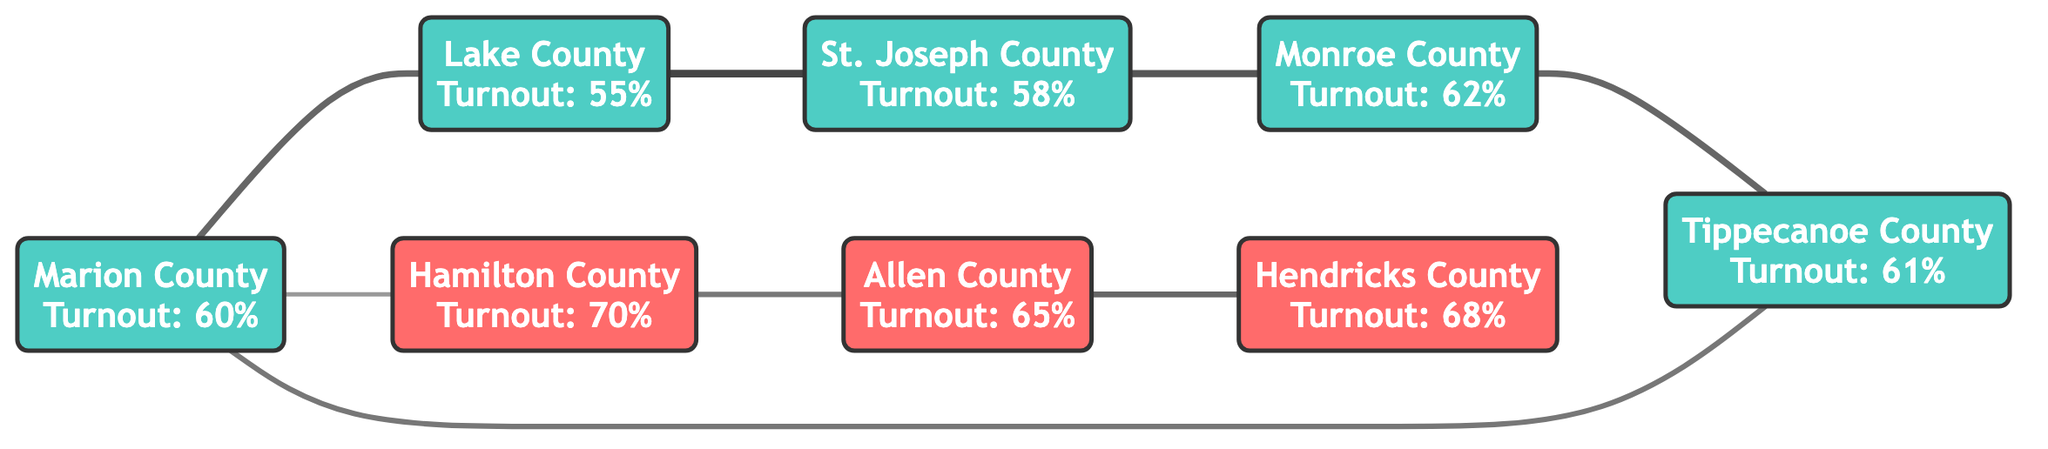What is the voter turnout percentage for Marion County? The diagram indicates the voter turnout for Marion County is specifically annotated as 60%.
Answer: 60% What party affiliation does Hamilton County have? The diagram shows that Hamilton County is categorized as having a Republican party affiliation.
Answer: Republican How many edges are present in the diagram? By counting the connections between the counties, there are a total of 8 edges indicated in the diagram.
Answer: 8 Which county has the highest voter turnout? By comparing the voter turnout percentages, Hamilton County has the highest voter turnout of 70% among the listed counties.
Answer: Hamilton County What is the similarity score between Allen County and Hendricks County? The similarity score that connects Allen County and Hendricks County is listed as 0.65 in the edges.
Answer: 0.65 Which counties are connected to St. Joseph County? St. Joseph County is directly connected to Lake County and Monroe County according to the edges shown in the diagram.
Answer: Lake County, Monroe County What is the lowest voter turnout percentage among the counties? Upon reviewing the turnout percentages, Lake County has the lowest voter turnout at 55%.
Answer: 55% Are there more Democratic or Republican counties in the diagram? Counting the nodes, there are 5 Democratic counties and 3 Republican counties, indicating that there are more Democratic counties.
Answer: Democratic Which county has a direct connection to both Monroe County and Marion County? The county that has a direct connection to both Monroe County and Marion County is Tippecanoe County, as depicted in the diagram with edges.
Answer: Tippecanoe County 